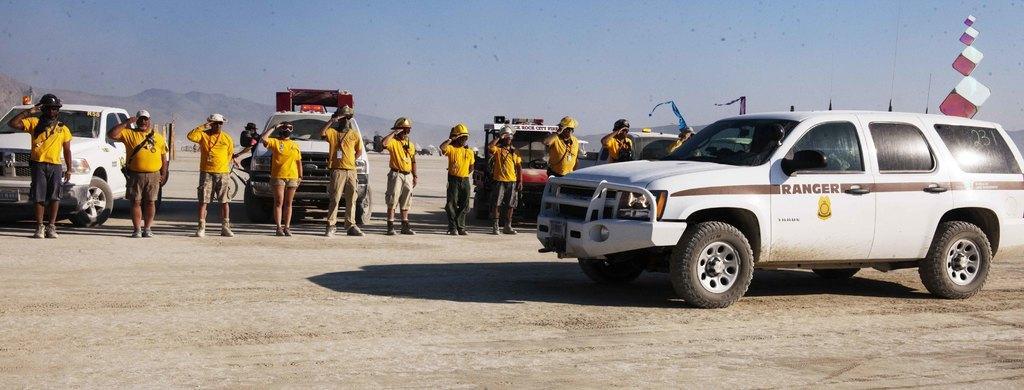In one or two sentences, can you explain what this image depicts? In this image we can see a car on the right side. Here we can see a few persons standing on the ground and they are doing honor salute. Here we can see the helmets on their heads. In the background, we can see the vehicles. 